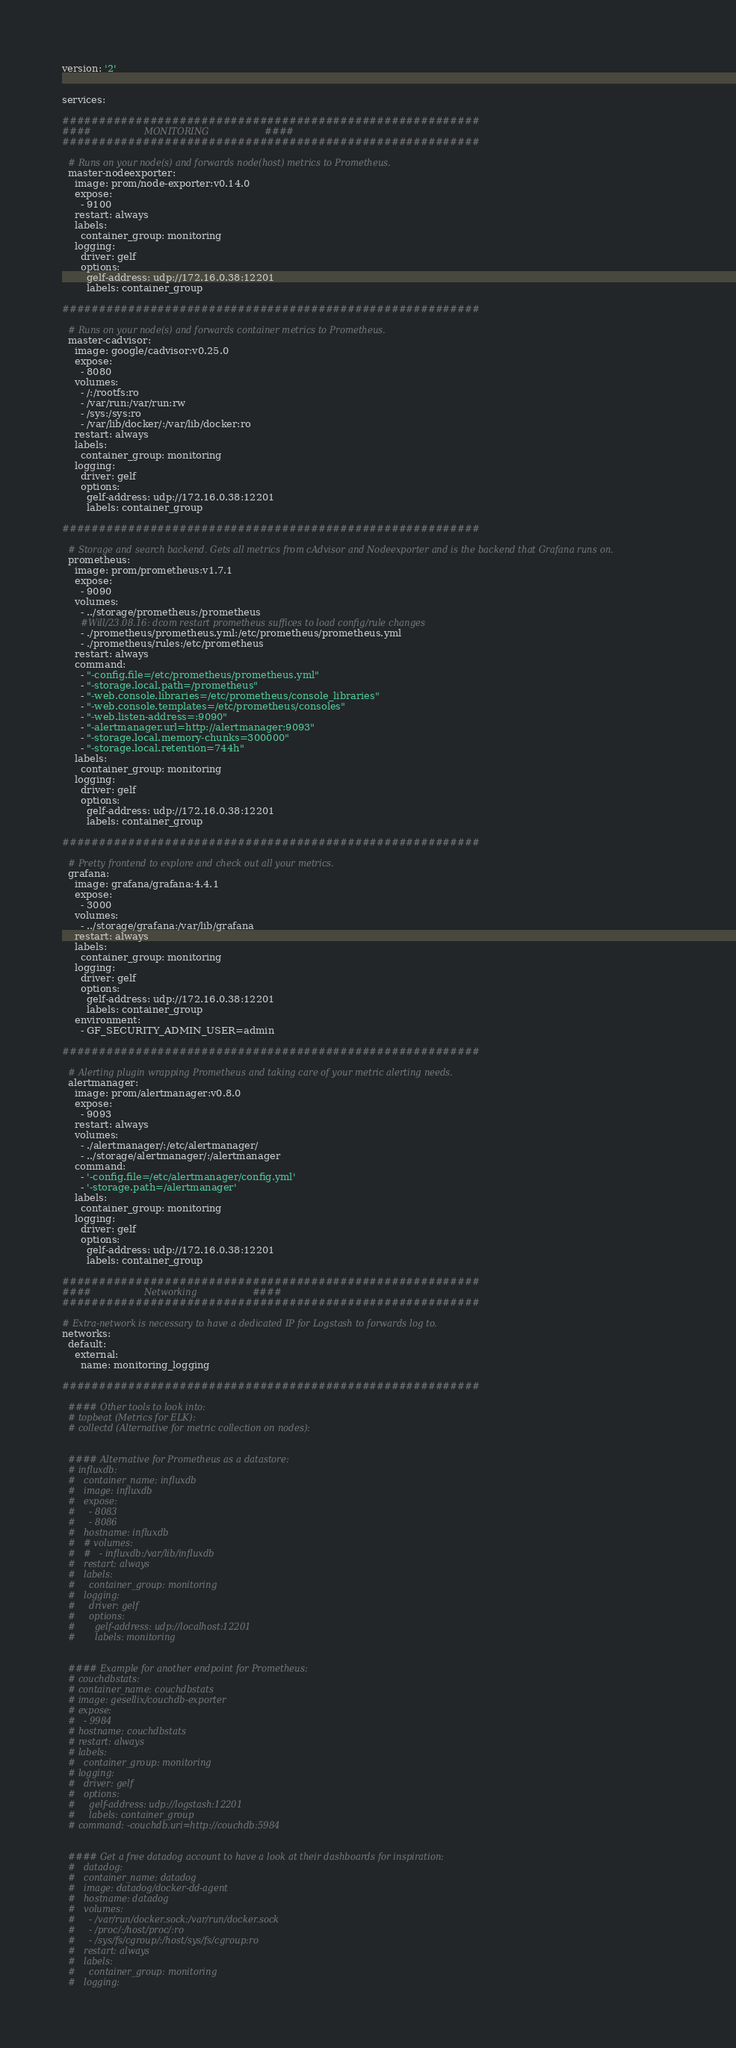<code> <loc_0><loc_0><loc_500><loc_500><_YAML_>version: '2'


services:

#########################################################
####                   MONITORING                    ####
#########################################################

  # Runs on your node(s) and forwards node(host) metrics to Prometheus.
  master-nodeexporter:
    image: prom/node-exporter:v0.14.0
    expose:
      - 9100
    restart: always
    labels:
      container_group: monitoring
    logging:
      driver: gelf
      options:
        gelf-address: udp://172.16.0.38:12201
        labels: container_group

#########################################################

  # Runs on your node(s) and forwards container metrics to Prometheus.
  master-cadvisor:
    image: google/cadvisor:v0.25.0
    expose:
      - 8080
    volumes:
      - /:/rootfs:ro
      - /var/run:/var/run:rw
      - /sys:/sys:ro
      - /var/lib/docker/:/var/lib/docker:ro
    restart: always
    labels:
      container_group: monitoring
    logging:
      driver: gelf
      options:
        gelf-address: udp://172.16.0.38:12201
        labels: container_group

#########################################################

  # Storage and search backend. Gets all metrics from cAdvisor and Nodeexporter and is the backend that Grafana runs on.
  prometheus:
    image: prom/prometheus:v1.7.1
    expose:
      - 9090
    volumes:
      - ../storage/prometheus:/prometheus
      #Will/23.08.16: dcom restart prometheus suffices to load config/rule changes
      - ./prometheus/prometheus.yml:/etc/prometheus/prometheus.yml
      - ./prometheus/rules:/etc/prometheus
    restart: always
    command:
      - "-config.file=/etc/prometheus/prometheus.yml"
      - "-storage.local.path=/prometheus"
      - "-web.console.libraries=/etc/prometheus/console_libraries"
      - "-web.console.templates=/etc/prometheus/consoles"
      - "-web.listen-address=:9090"
      - "-alertmanager.url=http://alertmanager:9093"
      - "-storage.local.memory-chunks=300000"
      - "-storage.local.retention=744h"
    labels:
      container_group: monitoring
    logging:
      driver: gelf
      options:
        gelf-address: udp://172.16.0.38:12201
        labels: container_group

#########################################################

  # Pretty frontend to explore and check out all your metrics.
  grafana:
    image: grafana/grafana:4.4.1
    expose:
      - 3000
    volumes:
      - ../storage/grafana:/var/lib/grafana
    restart: always
    labels:
      container_group: monitoring
    logging:
      driver: gelf
      options:
        gelf-address: udp://172.16.0.38:12201
        labels: container_group
    environment:
      - GF_SECURITY_ADMIN_USER=admin

#########################################################

  # Alerting plugin wrapping Prometheus and taking care of your metric alerting needs.
  alertmanager:
    image: prom/alertmanager:v0.8.0
    expose:
      - 9093
    restart: always
    volumes:
      - ./alertmanager/:/etc/alertmanager/
      - ../storage/alertmanager/:/alertmanager
    command:
      - '-config.file=/etc/alertmanager/config.yml'
      - '-storage.path=/alertmanager'
    labels:
      container_group: monitoring
    logging:
      driver: gelf
      options:
        gelf-address: udp://172.16.0.38:12201
        labels: container_group

#########################################################
####                   Networking                    ####
#########################################################

# Extra-network is necessary to have a dedicated IP for Logstash to forwards log to.
networks:
  default:
    external:
      name: monitoring_logging

#########################################################

  #### Other tools to look into:
  # topbeat (Metrics for ELK):
  # collectd (Alternative for metric collection on nodes):


  #### Alternative for Prometheus as a datastore:
  # influxdb:
  #   container_name: influxdb
  #   image: influxdb
  #   expose:
  #     - 8083
  #     - 8086
  #   hostname: influxdb
  #   # volumes:
  #   #   - influxdb:/var/lib/influxdb
  #   restart: always
  #   labels:
  #     container_group: monitoring
  #   logging:
  #     driver: gelf
  #     options:
  #       gelf-address: udp://localhost:12201
  #       labels: monitoring


  #### Example for another endpoint for Prometheus:
  # couchdbstats:
  # container_name: couchdbstats
  # image: gesellix/couchdb-exporter
  # expose:
  #   - 9984
  # hostname: couchdbstats
  # restart: always
  # labels:
  #   container_group: monitoring
  # logging:
  #   driver: gelf
  #   options:
  #     gelf-address: udp://logstash:12201
  #     labels: container_group
  # command: -couchdb.uri=http://couchdb:5984


  #### Get a free datadog account to have a look at their dashboards for inspiration:
  #   datadog:
  #   container_name: datadog
  #   image: datadog/docker-dd-agent
  #   hostname: datadog
  #   volumes:
  #     - /var/run/docker.sock:/var/run/docker.sock
  #     - /proc/:/host/proc/:ro
  #     - /sys/fs/cgroup/:/host/sys/fs/cgroup:ro
  #   restart: always
  #   labels:
  #     container_group: monitoring
  #   logging:</code> 